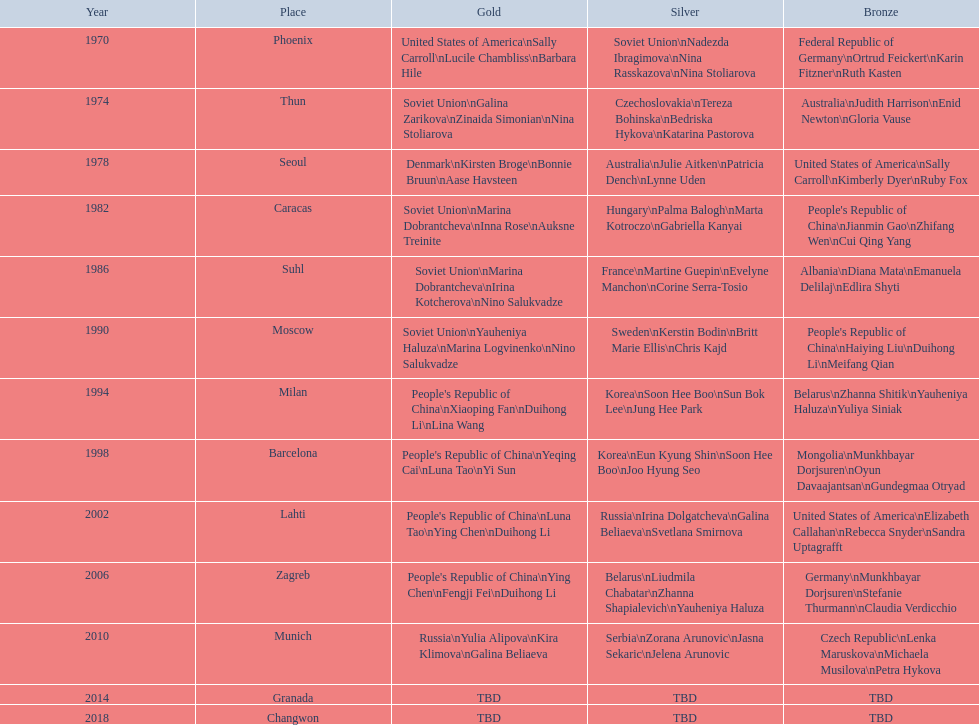Whose name is listed before bonnie bruun's in the gold column? Kirsten Broge. 